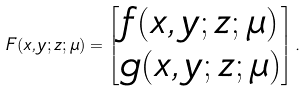<formula> <loc_0><loc_0><loc_500><loc_500>F ( x , y ; z ; \mu ) = \begin{bmatrix} f ( x , y ; z ; \mu ) \\ g ( x , y ; z ; \mu ) \end{bmatrix} .</formula> 